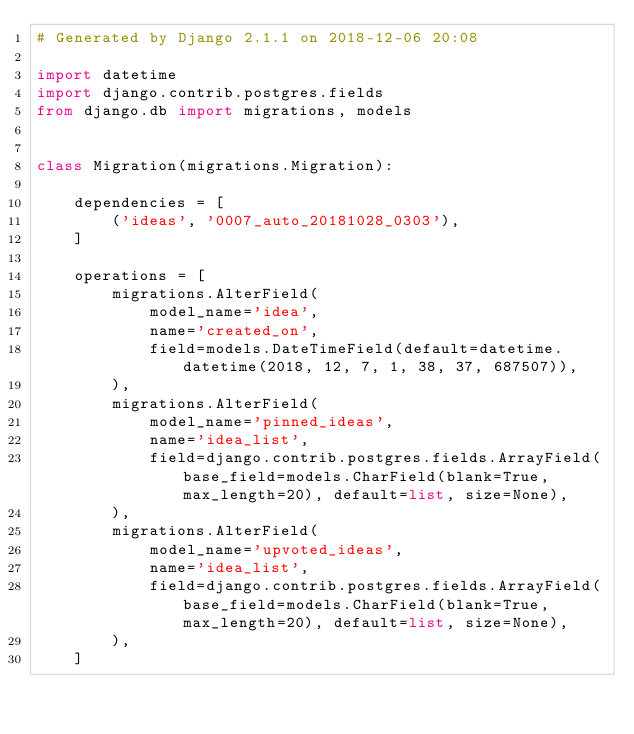<code> <loc_0><loc_0><loc_500><loc_500><_Python_># Generated by Django 2.1.1 on 2018-12-06 20:08

import datetime
import django.contrib.postgres.fields
from django.db import migrations, models


class Migration(migrations.Migration):

    dependencies = [
        ('ideas', '0007_auto_20181028_0303'),
    ]

    operations = [
        migrations.AlterField(
            model_name='idea',
            name='created_on',
            field=models.DateTimeField(default=datetime.datetime(2018, 12, 7, 1, 38, 37, 687507)),
        ),
        migrations.AlterField(
            model_name='pinned_ideas',
            name='idea_list',
            field=django.contrib.postgres.fields.ArrayField(base_field=models.CharField(blank=True, max_length=20), default=list, size=None),
        ),
        migrations.AlterField(
            model_name='upvoted_ideas',
            name='idea_list',
            field=django.contrib.postgres.fields.ArrayField(base_field=models.CharField(blank=True, max_length=20), default=list, size=None),
        ),
    ]
</code> 